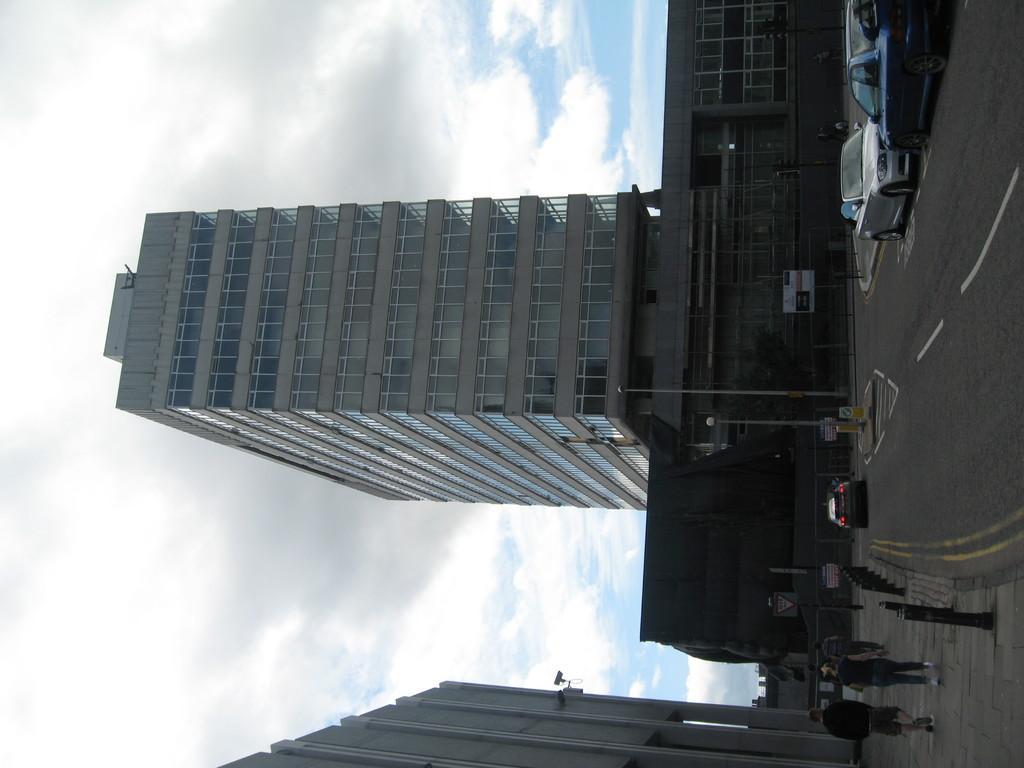How would you summarize this image in a sentence or two? This image is in left direction. On the right side there are few cars on the road. At the bottom few people are walking on the footpath and there is a railing. In the middle of the image there are few buildings. On the left side, I can see the sky and clouds. 